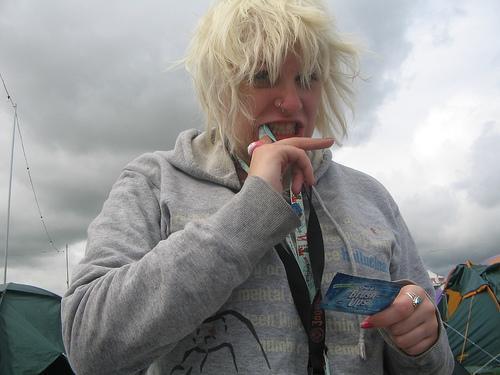How many windows on this airplane are touched by red or orange paint?
Give a very brief answer. 0. 